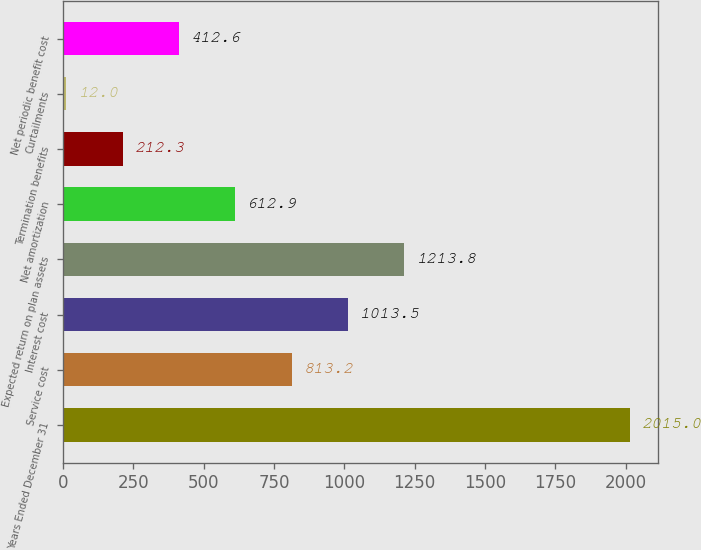Convert chart to OTSL. <chart><loc_0><loc_0><loc_500><loc_500><bar_chart><fcel>Years Ended December 31<fcel>Service cost<fcel>Interest cost<fcel>Expected return on plan assets<fcel>Net amortization<fcel>Termination benefits<fcel>Curtailments<fcel>Net periodic benefit cost<nl><fcel>2015<fcel>813.2<fcel>1013.5<fcel>1213.8<fcel>612.9<fcel>212.3<fcel>12<fcel>412.6<nl></chart> 